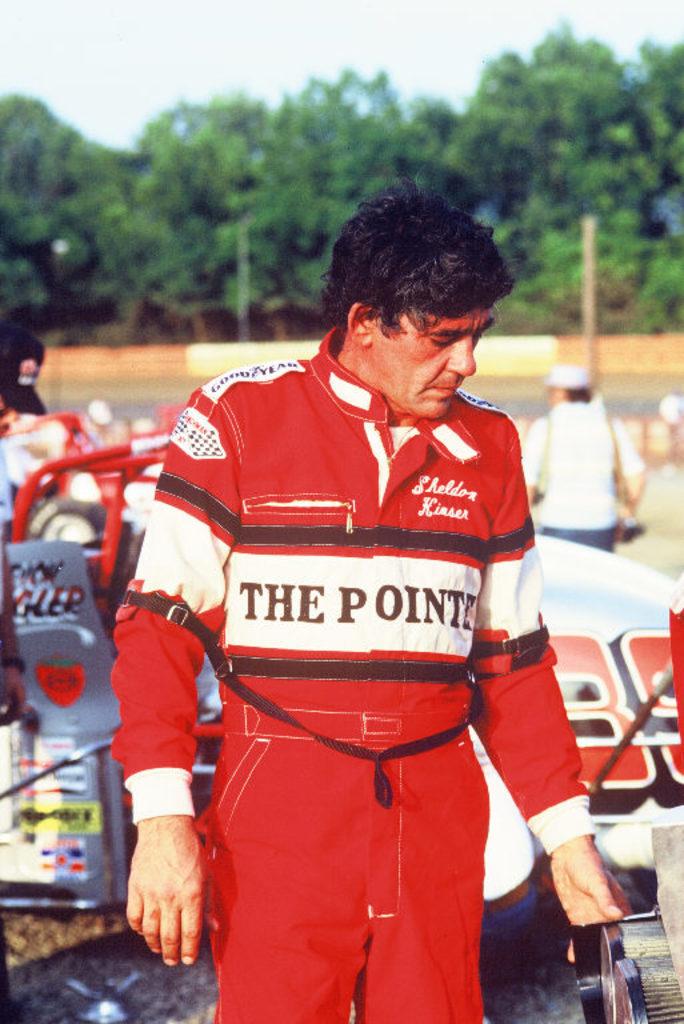What is on the front of his shirt?
Provide a short and direct response. The pointe. What is advertised on his shoulders?
Give a very brief answer. Good year. 